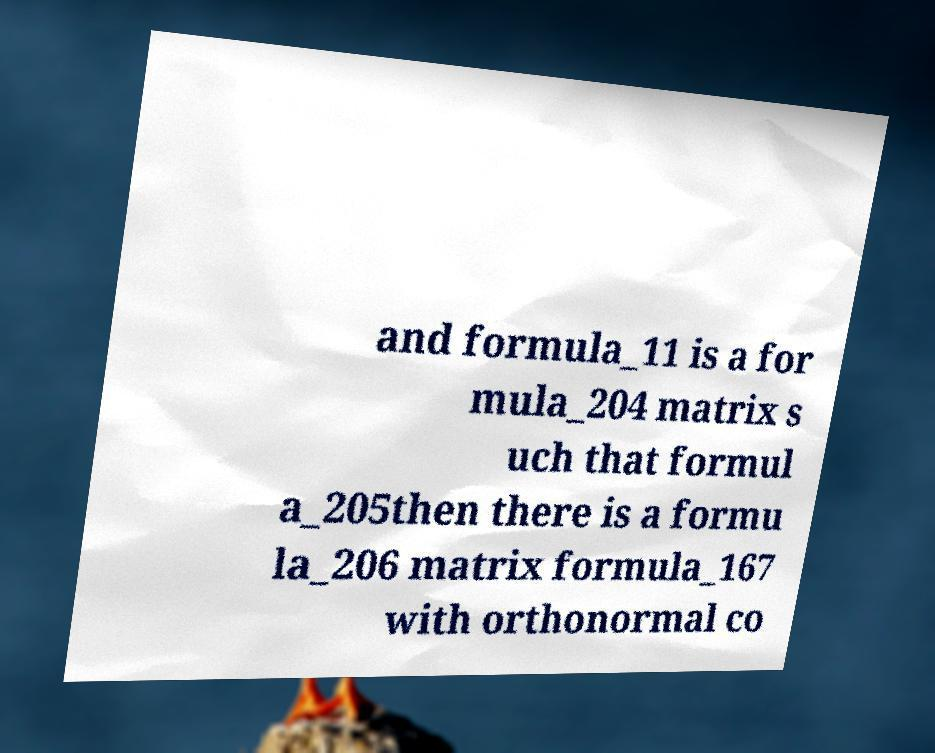Can you accurately transcribe the text from the provided image for me? and formula_11 is a for mula_204 matrix s uch that formul a_205then there is a formu la_206 matrix formula_167 with orthonormal co 